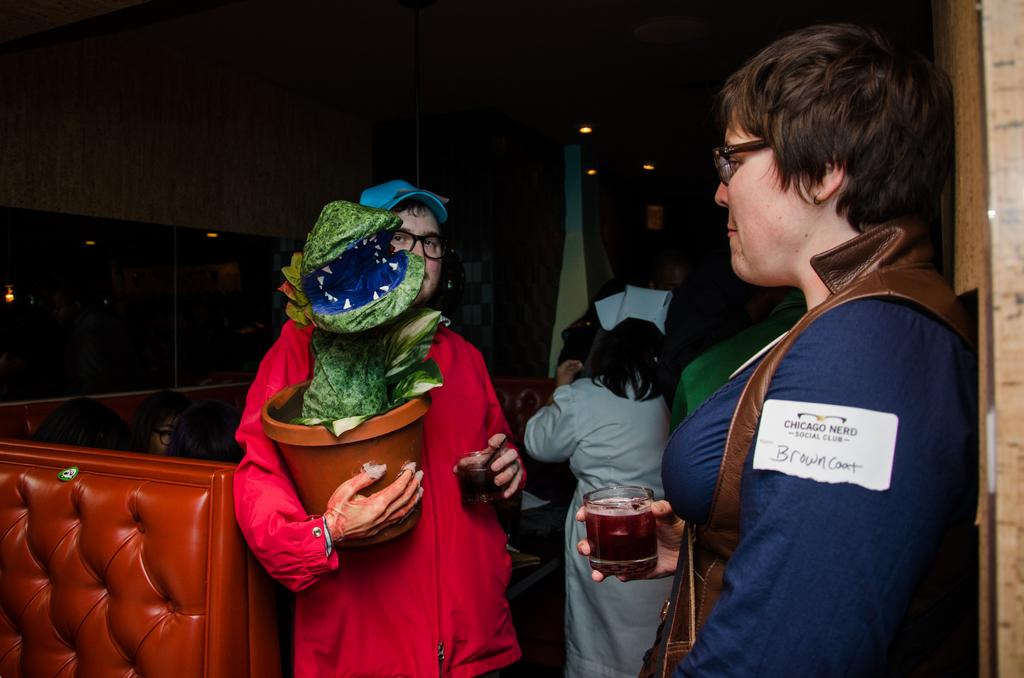What are the people in the image doing? The people in the image are standing and holding glasses. Is there anything else in the hands of the people? One person is holding a pot. What type of furniture is near the people? There is a couch beside the people. Can you see a parrot sitting on the car in the image? No, there is no parrot present in the image. Is the car parked near the ocean in the image? No, the image does not show any ocean or body of water. 